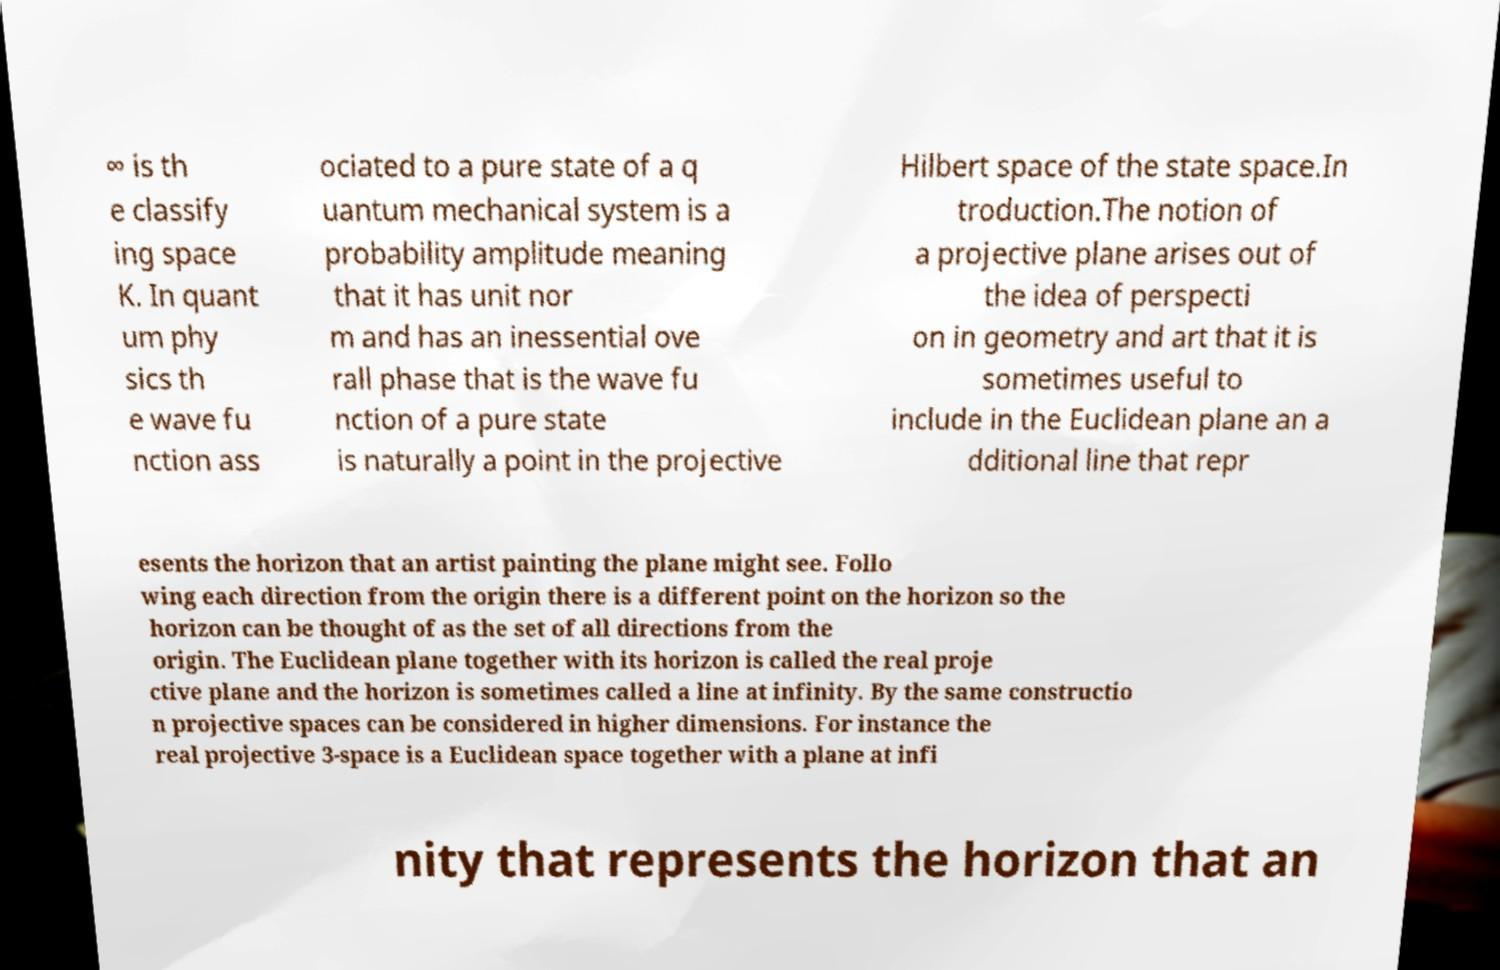There's text embedded in this image that I need extracted. Can you transcribe it verbatim? ∞ is th e classify ing space K. In quant um phy sics th e wave fu nction ass ociated to a pure state of a q uantum mechanical system is a probability amplitude meaning that it has unit nor m and has an inessential ove rall phase that is the wave fu nction of a pure state is naturally a point in the projective Hilbert space of the state space.In troduction.The notion of a projective plane arises out of the idea of perspecti on in geometry and art that it is sometimes useful to include in the Euclidean plane an a dditional line that repr esents the horizon that an artist painting the plane might see. Follo wing each direction from the origin there is a different point on the horizon so the horizon can be thought of as the set of all directions from the origin. The Euclidean plane together with its horizon is called the real proje ctive plane and the horizon is sometimes called a line at infinity. By the same constructio n projective spaces can be considered in higher dimensions. For instance the real projective 3-space is a Euclidean space together with a plane at infi nity that represents the horizon that an 